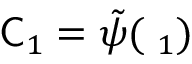Convert formula to latex. <formula><loc_0><loc_0><loc_500><loc_500>\mathsf C _ { 1 } = \tilde { \psi } ( \mathbf \Delta _ { 1 } )</formula> 